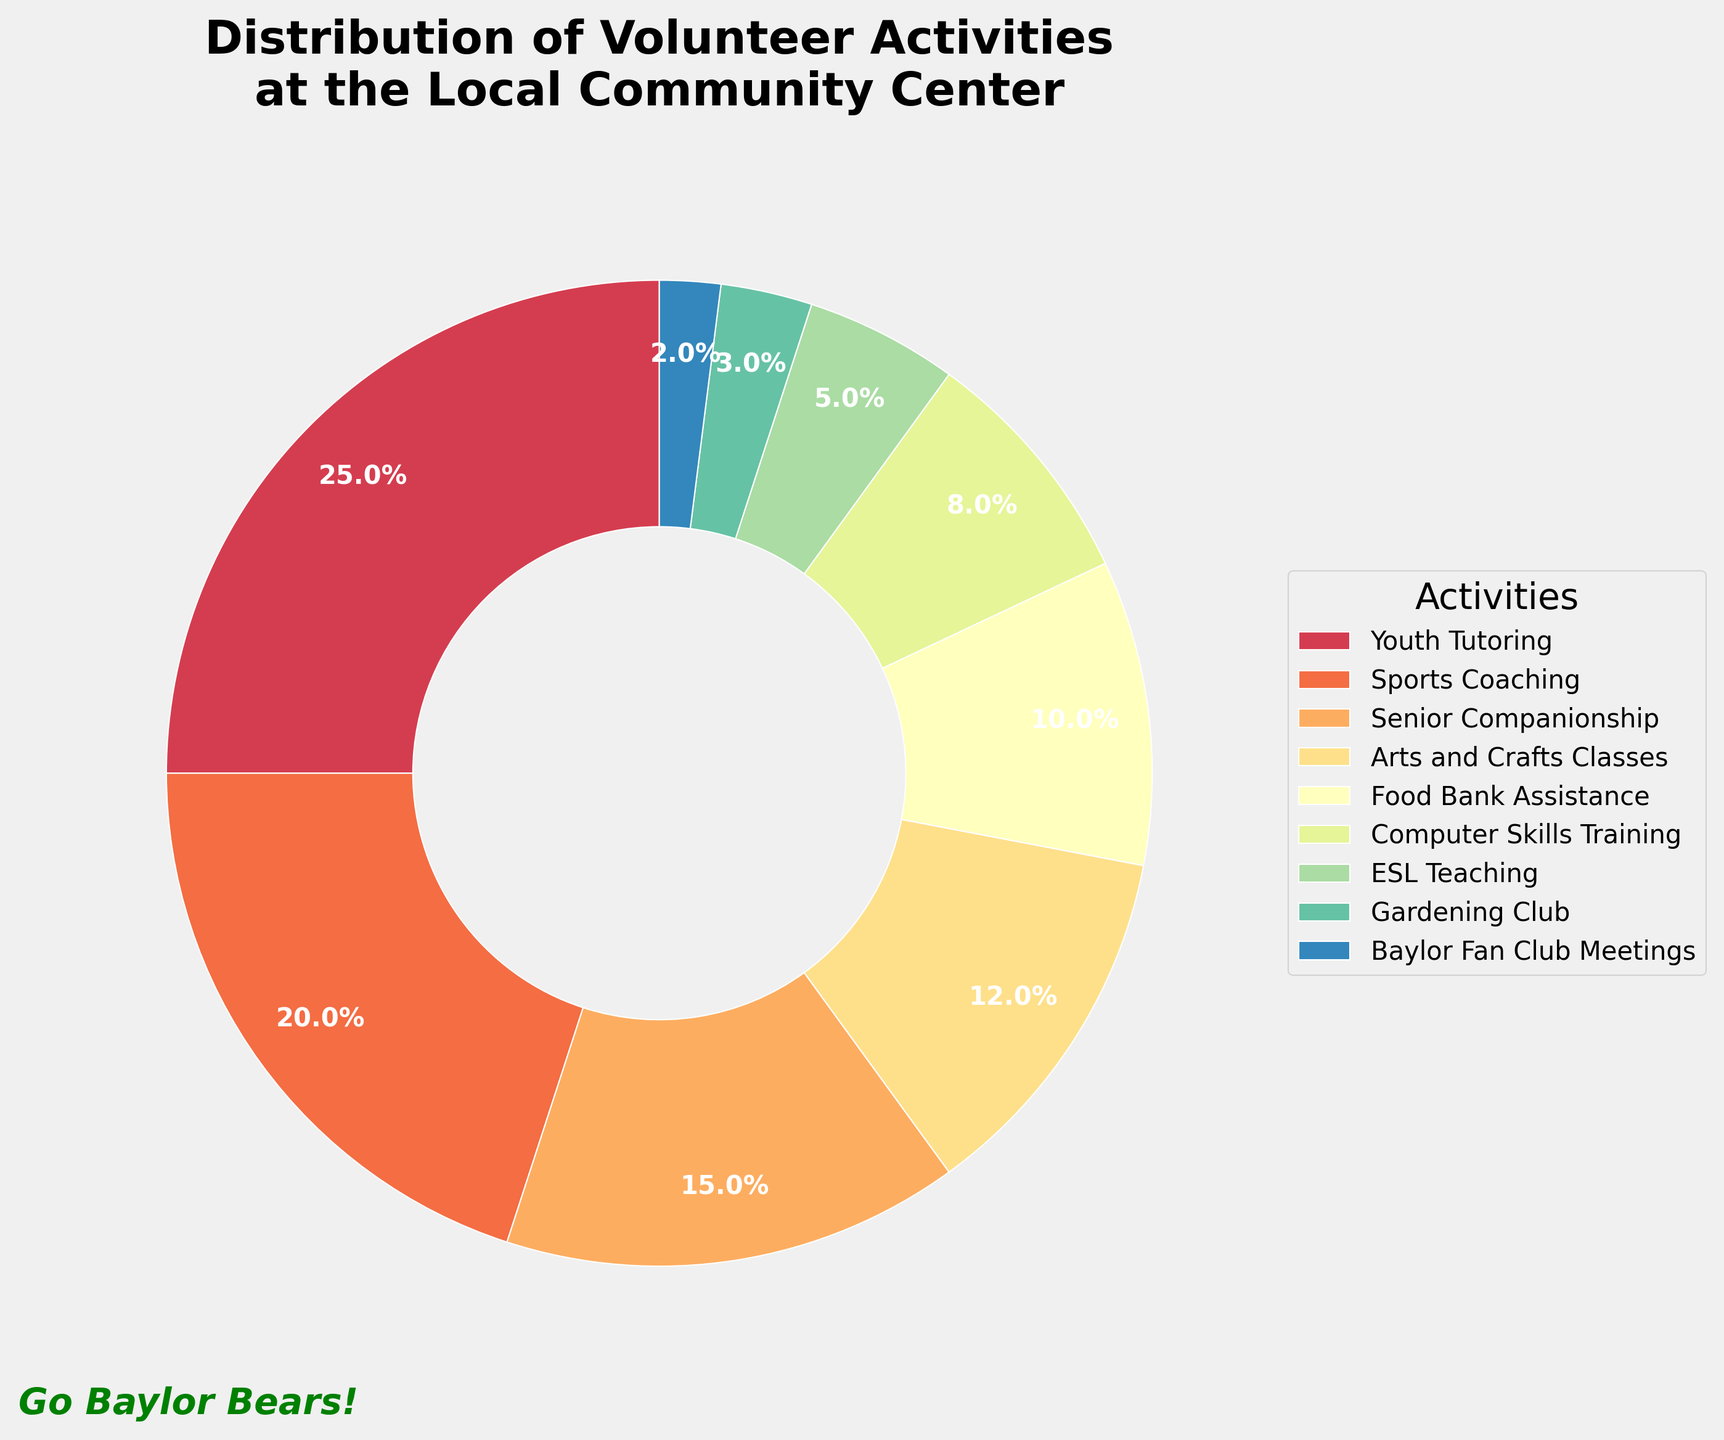Which activity has the highest percentage? The pie chart shows the percentage distribution of various volunteer activities. The segment with the largest area or the highest percentage is Youth Tutoring at 25%.
Answer: Youth Tutoring How much more percentage does Sports Coaching have compared to ESL Teaching? Compare the percentages of Sports Coaching (20%) and ESL Teaching (5%). Subtract 5% from 20% to find the difference.
Answer: 15% What are the combined percentages of Arts and Crafts Classes and Food Bank Assistance? Add the percentages of Arts and Crafts Classes (12%) and Food Bank Assistance (10%). The sum is 12% + 10%.
Answer: 22% Which two activities contribute to half of the total percentage? Combining the two largest percentages, Youth Tutoring (25%) and Sports Coaching (20%), gives us 25% + 20% = 45%. Adjusting, we need the next largest to reach close to 50%. Youth Tutoring (25%) and Senior Companionship (15%) give a total of 25% + 15% = 40%. So, adding 5% ESL Teaching gives 50%. Therefore, no two activities alone do, but Youth Tutoring, Sports Coaching, Senior Companionship, and ESL comes close with detailed combing.
Answer: No two activities alone What is the combined percentage of Youth Tutoring and Baylor Fan Club Meetings? The percentages for Youth Tutoring and Baylor Fan Club Meetings are 25% and 2% respectively. Adding them gives 25% + 2%.
Answer: 27% Which activity has the smallest percentage? The segment with the smallest area in the pie chart represents the activity with the smallest percentage. This is Baylor Fan Club Meetings at 2%.
Answer: Baylor Fan Club Meetings How does the percentage of Computer Skills Training compare to that of Arts and Crafts Classes? Compare the slices. Computer Skills Training is 8% while Arts and Crafts Classes is 12%. Thus, Computer Skills Training is 4 percentage points less than Arts and Crafts Classes.
Answer: 4 percentage points less What's the visual difference between the wedge for Youth Tutoring and the wedge for Gardening Club? Youth Tutoring has a much larger wedge compared to Gardening Club. Youth Tutoring is 25% while Gardening Club is only 3%, thus visibly occupying less space in the pie chart.
Answer: Youth Tutoring wedge is significantly larger What percentage of activities involve teaching skills (Youth Tutoring, Computer Skills Training, and ESL Teaching)? Sum the percentages of Youth Tutoring (25%), Computer Skills Training (8%), and ESL Teaching (5%). 25% + 8% + 5% = 38%.
Answer: 38% 